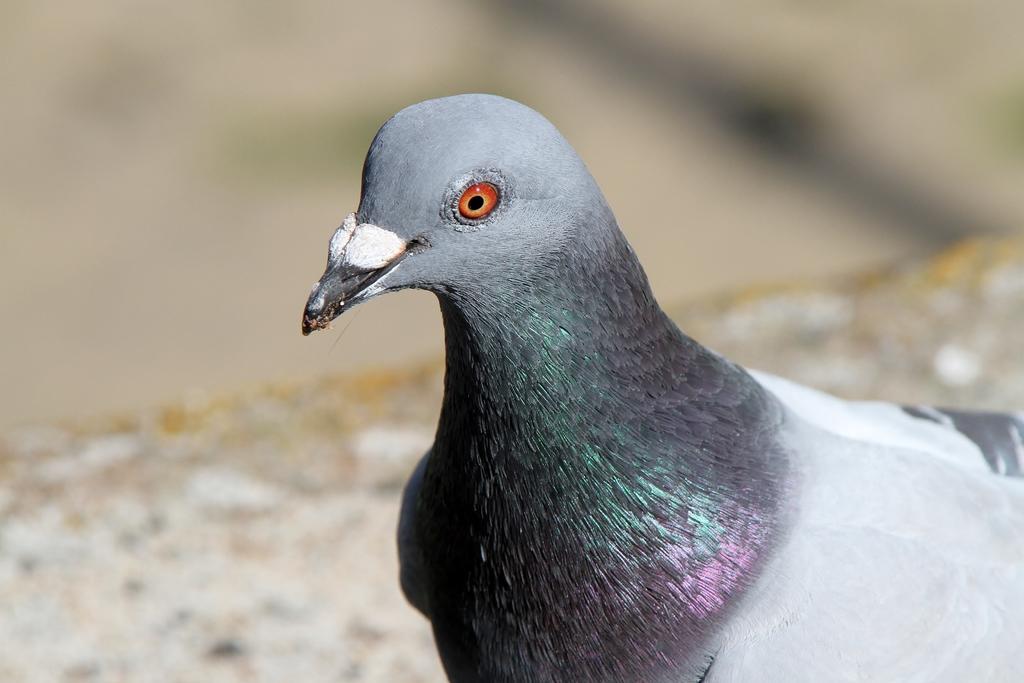How would you summarize this image in a sentence or two? In this image I see a pigeon which is of grey, white, black, green and pink in color and it is blurred in the background. 